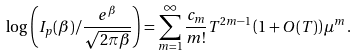<formula> <loc_0><loc_0><loc_500><loc_500>\log \left ( I _ { p } ( \beta ) / \frac { e ^ { \beta } } { \sqrt { 2 \pi \beta } } \right ) = \sum _ { m = 1 } ^ { \infty } \frac { c _ { m } } { m ! } T ^ { 2 m - 1 } \left ( 1 + O ( T ) \right ) \mu ^ { m } .</formula> 